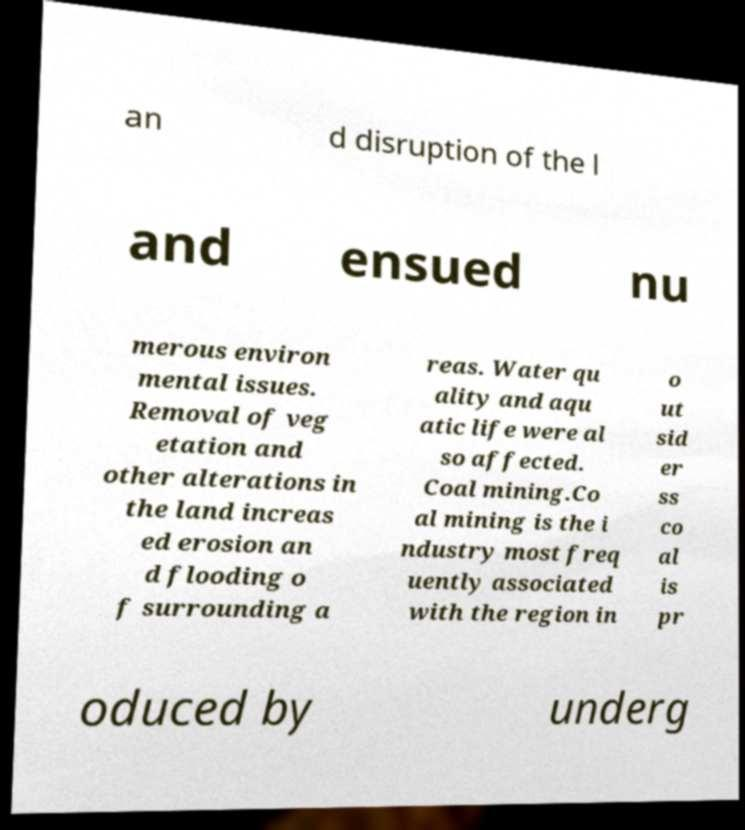Can you read and provide the text displayed in the image?This photo seems to have some interesting text. Can you extract and type it out for me? an d disruption of the l and ensued nu merous environ mental issues. Removal of veg etation and other alterations in the land increas ed erosion an d flooding o f surrounding a reas. Water qu ality and aqu atic life were al so affected. Coal mining.Co al mining is the i ndustry most freq uently associated with the region in o ut sid er ss co al is pr oduced by underg 